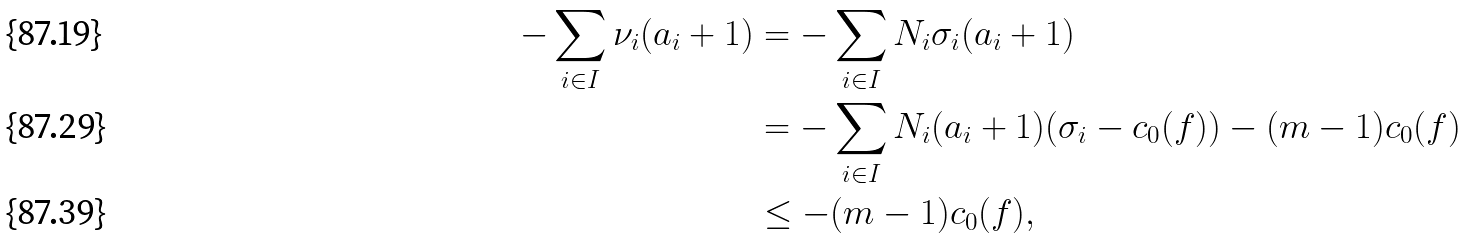<formula> <loc_0><loc_0><loc_500><loc_500>- \sum _ { i \in I } \nu _ { i } ( a _ { i } + 1 ) & = - \sum _ { i \in I } N _ { i } \sigma _ { i } ( a _ { i } + 1 ) \\ & = - \sum _ { i \in I } N _ { i } ( a _ { i } + 1 ) ( \sigma _ { i } - c _ { 0 } ( f ) ) - ( m - 1 ) c _ { 0 } ( f ) \\ & \leq - ( m - 1 ) c _ { 0 } ( f ) ,</formula> 